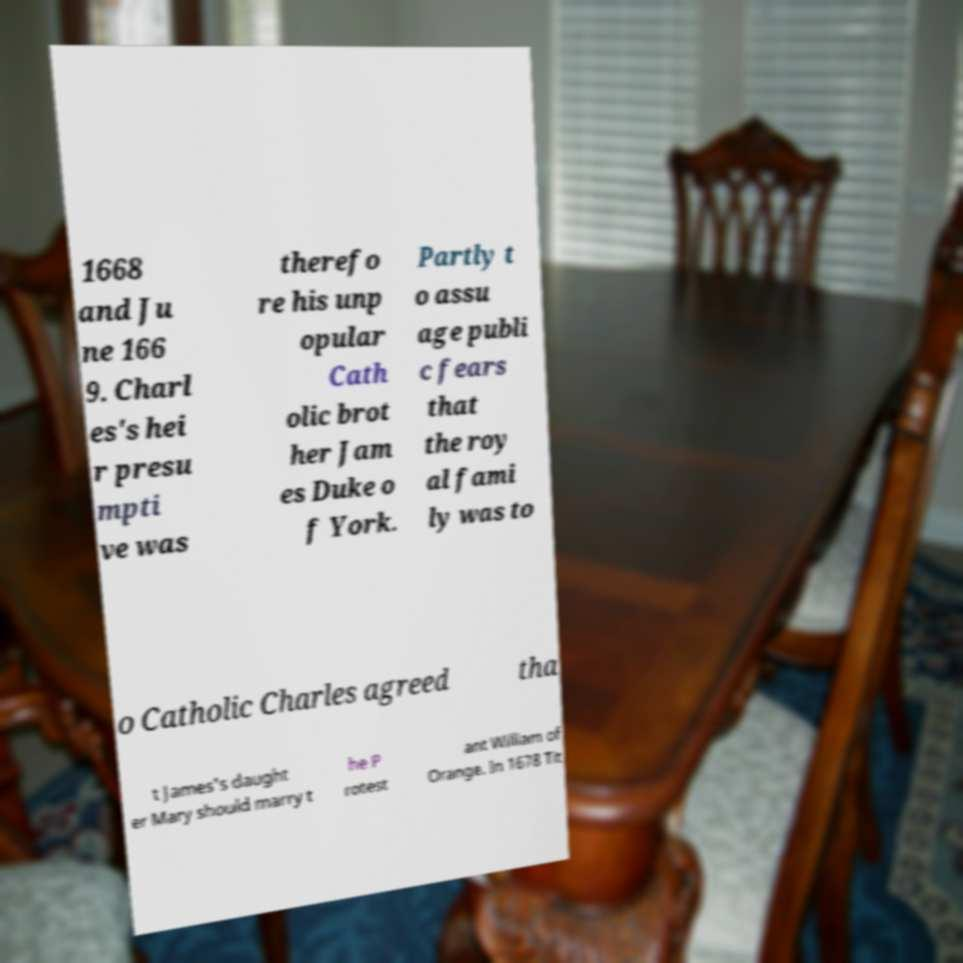I need the written content from this picture converted into text. Can you do that? 1668 and Ju ne 166 9. Charl es's hei r presu mpti ve was therefo re his unp opular Cath olic brot her Jam es Duke o f York. Partly t o assu age publi c fears that the roy al fami ly was to o Catholic Charles agreed tha t James's daught er Mary should marry t he P rotest ant William of Orange. In 1678 Tit 